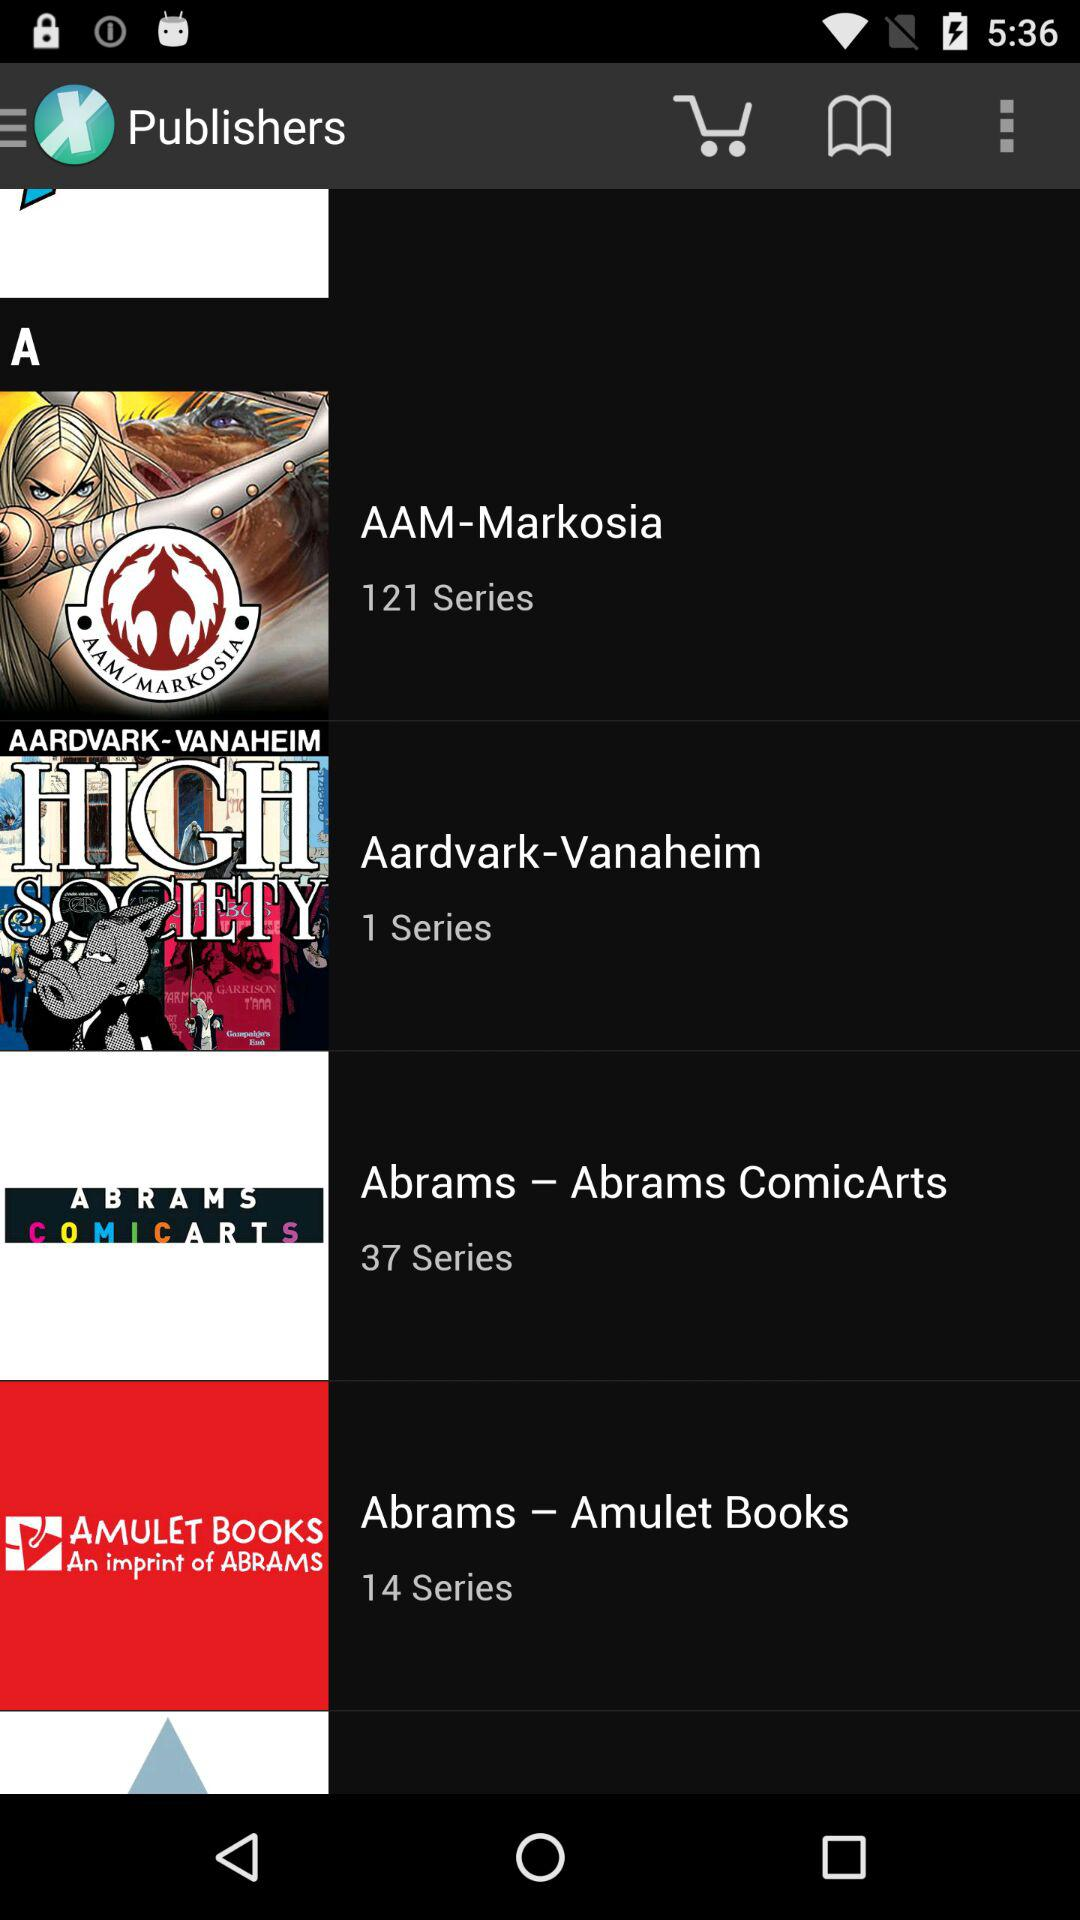How many series are there in "Abrams - Abrams ComicArts"? There are 37 series. 